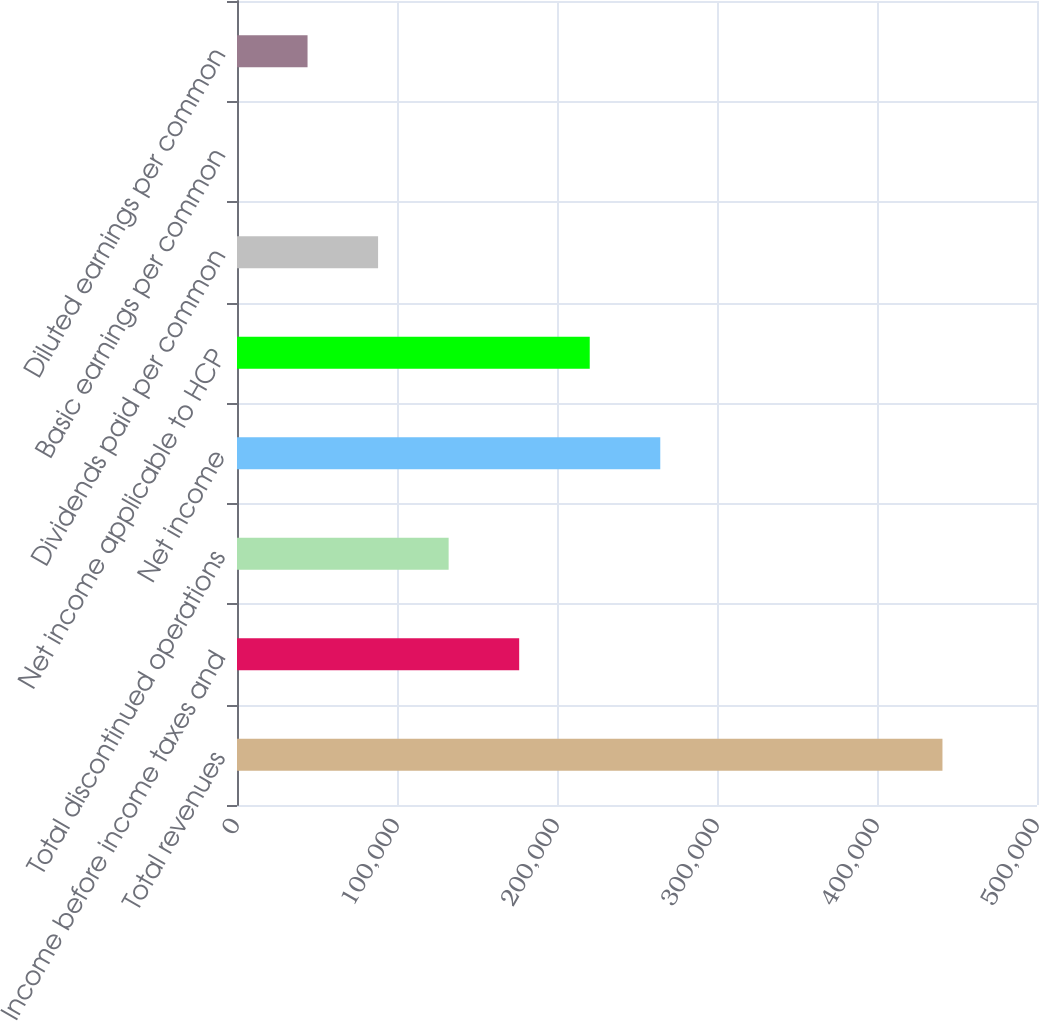<chart> <loc_0><loc_0><loc_500><loc_500><bar_chart><fcel>Total revenues<fcel>Income before income taxes and<fcel>Total discontinued operations<fcel>Net income<fcel>Net income applicable to HCP<fcel>Dividends paid per common<fcel>Basic earnings per common<fcel>Diluted earnings per common<nl><fcel>440914<fcel>176366<fcel>132274<fcel>264549<fcel>220457<fcel>88183.1<fcel>0.41<fcel>44091.8<nl></chart> 